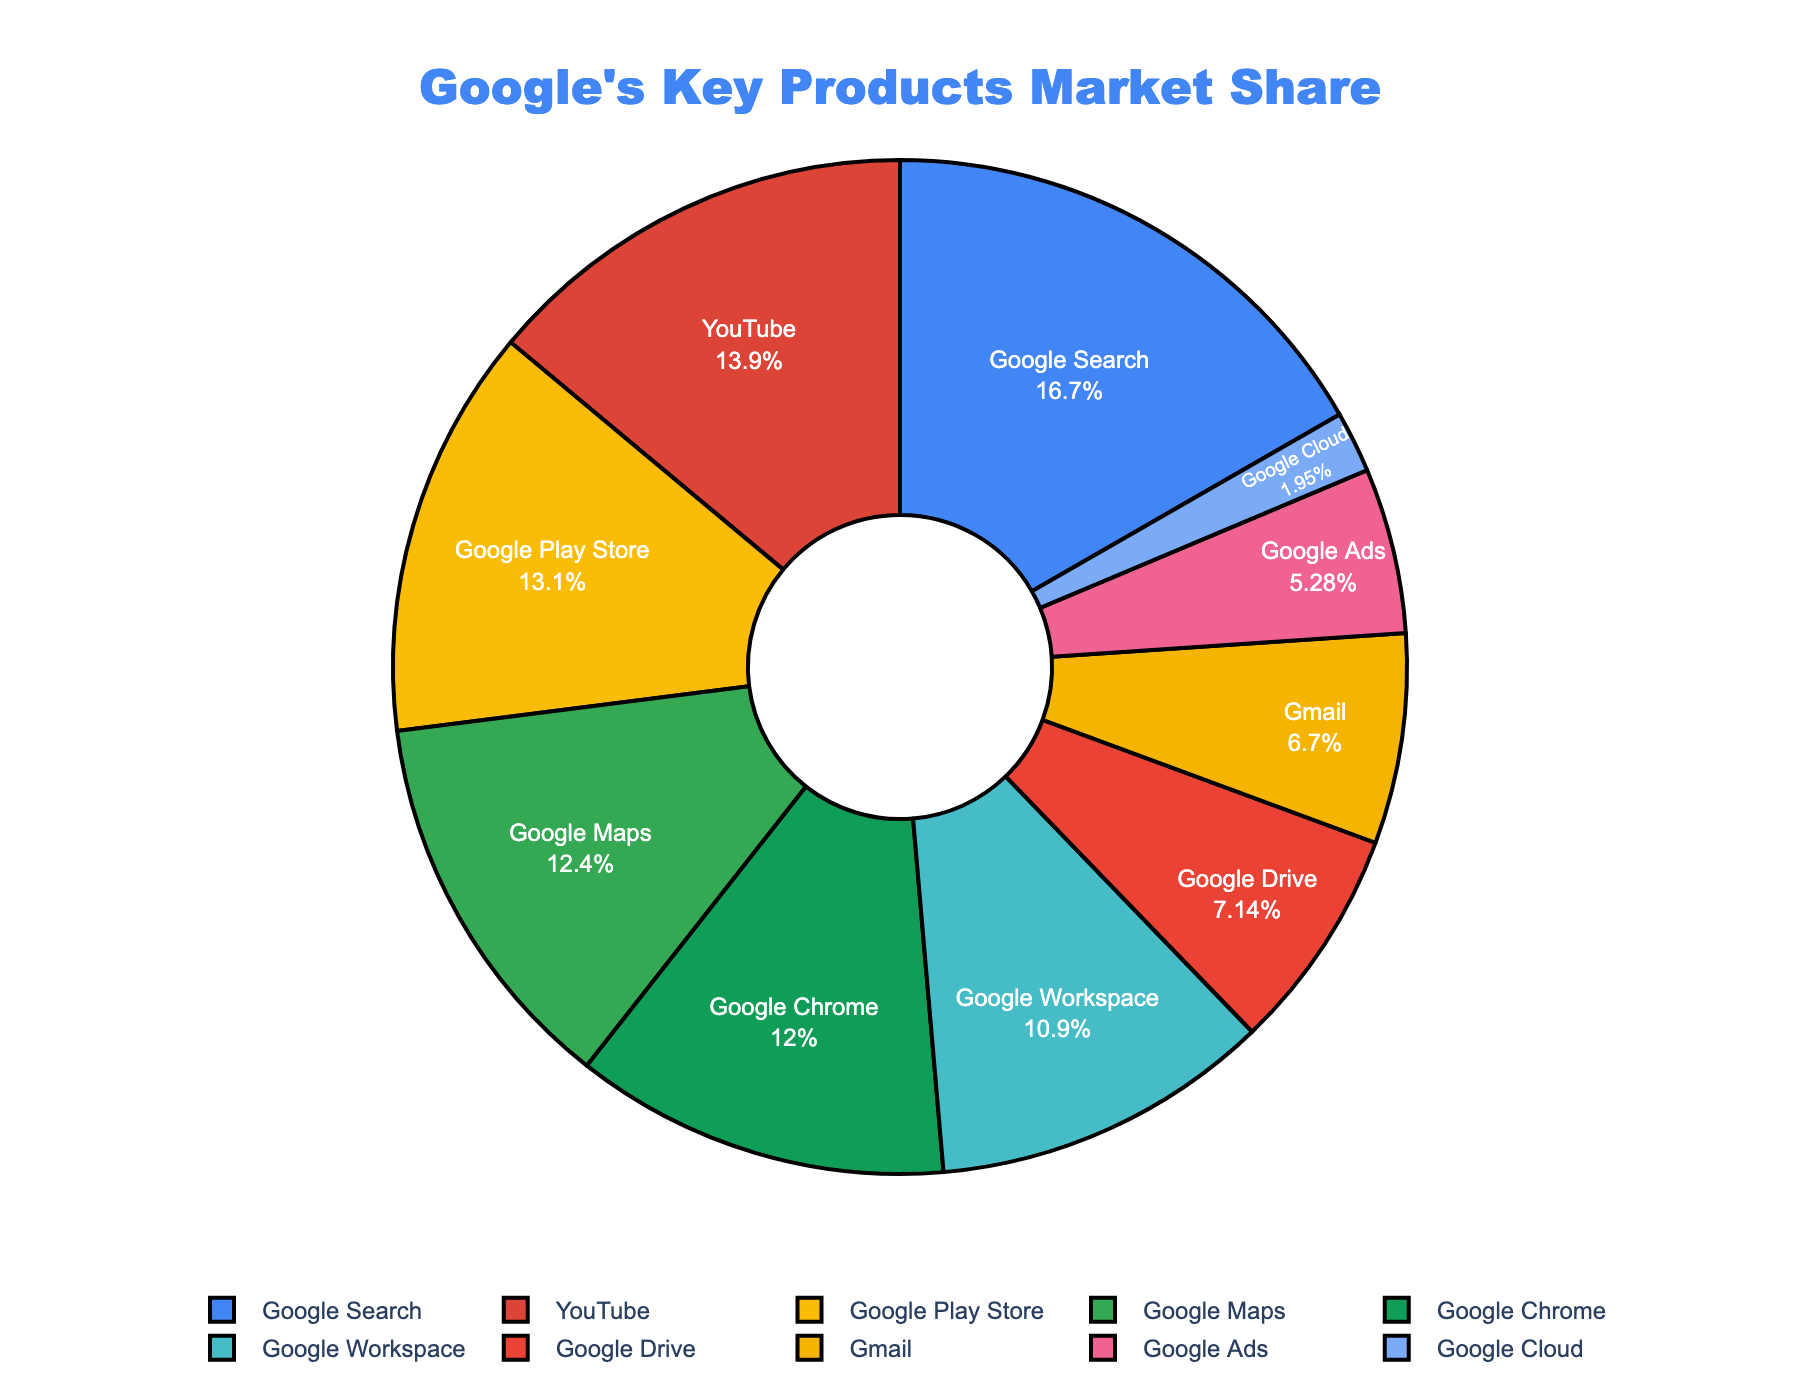What's the total market share of Google Search and YouTube combined? Google's Search has a market share of 91.42%, and YouTube has 76.3%. By adding these values together, the combined market share is 91.42 + 76.3 = 167.72
Answer: 167.72 Which product has a higher market share, Google Maps or Google Drive? By comparing the market shares, Google Maps has 67.8% and Google Drive has 39.1%. Since 67.8 is greater than 39.1, Google Maps has a higher market share.
Answer: Google Maps What is the difference in market share between Google Chrome and Google Cloud? Google Chrome has a market share of 65.52%, and Google Cloud has 10.7%. The difference is 65.52 - 10.7 = 54.82
Answer: 54.82 Which product has the largest market share? Observing the market share values, Google Search has the highest market share at 91.42%.
Answer: Google Search If the market shares of Gmail and Google Ads are combined, do they surpass Google Chrome's market share? Gmail has a market share of 36.7% and Google Ads has 28.9%. The combined market share is 36.7 + 28.9 = 65.6. Comparing this to Google Chrome's market share of 65.52, 65.6 is greater than 65.52.
Answer: Yes Which product has the third-largest market share? The top three market share values are from Google Search (91.42%), YouTube (76.3%), and Google Play Store (71.6%). Therefore, Google Play Store has the third-largest market share.
Answer: Google Play Store What is the average market share of Google Workspace, Google Drive, and Google Play Store? The market shares are Google Workspace (59.4%), Google Drive (39.1%), and Google Play Store (71.6%). The average is calculated as (59.4 + 39.1 + 71.6) / 3 = 56.7
Answer: 56.7 Which product has the lowest market share? Observing the chart, Google Cloud has the lowest market share at 10.7%.
Answer: Google Cloud 